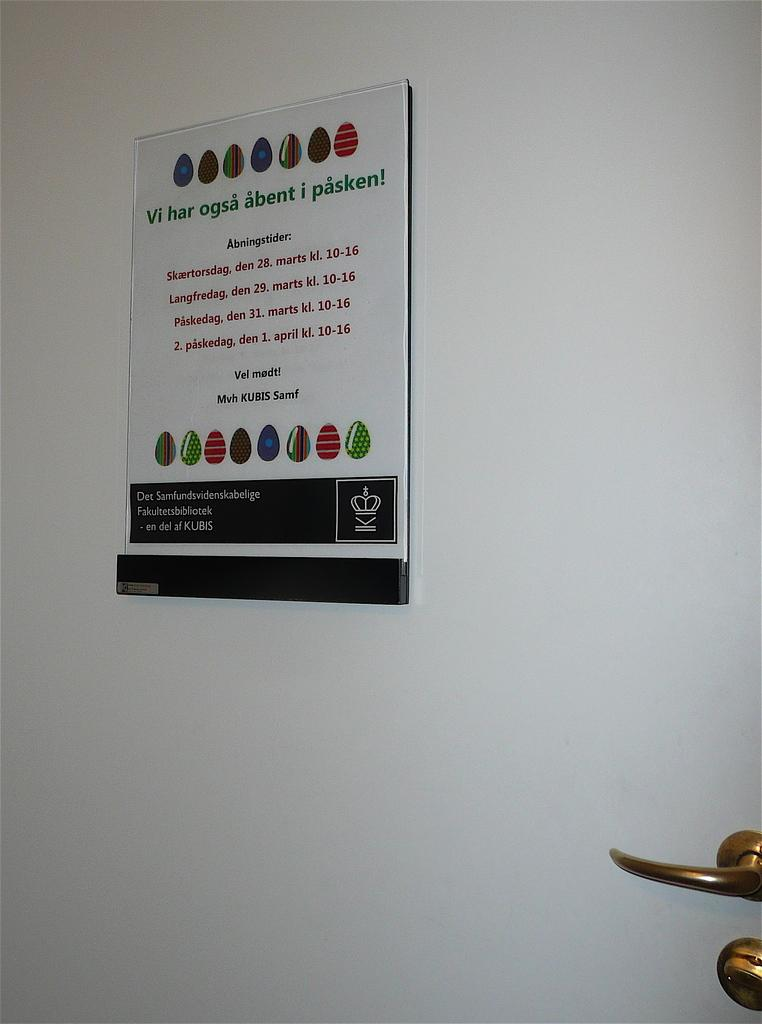What is a prominent feature in the image? There is a door in the image. What part of the door is visible in the image? There is a door knob in the image. What is written or displayed on a board in the image? There is a board with text in the image. Is there any additional information provided on the board? There is a label on the board in the image. Can you see any quicksand in the image? No, there is no quicksand present in the image. What type of toothbrush is shown in the image? There is no toothbrush present in the image. 